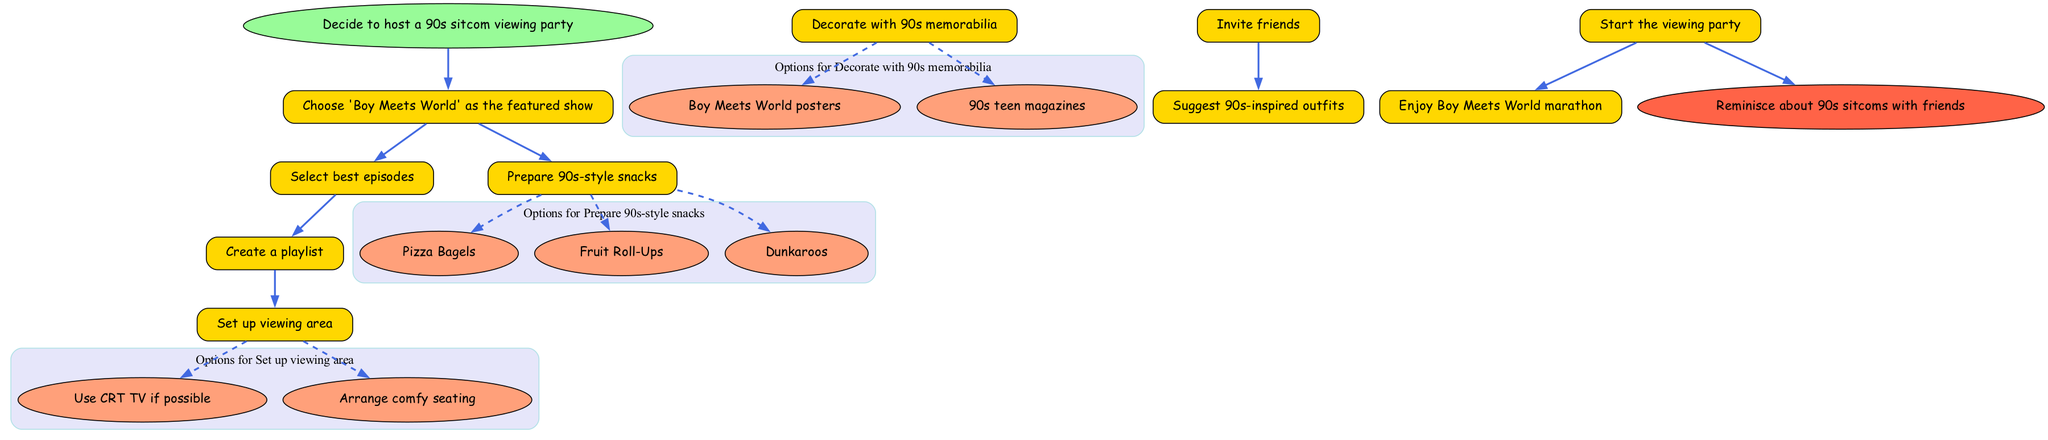What is the first step in the flow chart? The first step in the flow chart is the 'Decide to host a 90s sitcom viewing party' which serves as the starting point.
Answer: Decide to host a 90s sitcom viewing party How many main steps are identified in the diagram? The diagram lists a total of 8 main steps including the start and end points, which gives a count of 6 steps plus the start and end.
Answer: 8 What must you prepare after choosing 'Boy Meets World' as the featured show? After selecting 'Boy Meets World', the next steps are to 'Select best episodes' and 'Prepare 90s-style snacks' indicating two actions to undertake.
Answer: Select best episodes and Prepare 90s-style snacks What are the options for snacks you can prepare? The options listed under 'Prepare 90s-style snacks' include 'Pizza Bagels', 'Fruit Roll-Ups', and 'Dunkaroos', which are all nostalgic snacks from the 90s.
Answer: Pizza Bagels, Fruit Roll-Ups, Dunkaroos What is the final action depicted in the flow chart? The final action before concluding the process is 'Reminisce about 90s sitcoms with friends', highlighting what to do after the viewing party is over.
Answer: Reminisce about 90s sitcoms with friends Which step suggests decorating with 90s memorabilia? The step that specifically mentions this suggests 'Decorate with 90s memorabilia', which indicates an important aspect of the party's ambiance.
Answer: Decorate with 90s memorabilia How many options are available for setting up the viewing area? There are two options listed under 'Set up viewing area', which are 'Use CRT TV if possible' and 'Arrange comfy seating'.
Answer: 2 What must be done after inviting friends? After inviting friends, the next action in the sequence is to 'Suggest 90s-inspired outfits', indicating the flow of planning the party.
Answer: Suggest 90s-inspired outfits 